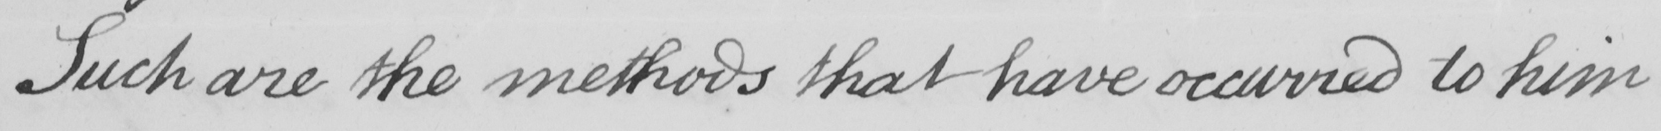Please transcribe the handwritten text in this image. Such are the methods that have occurred to him 